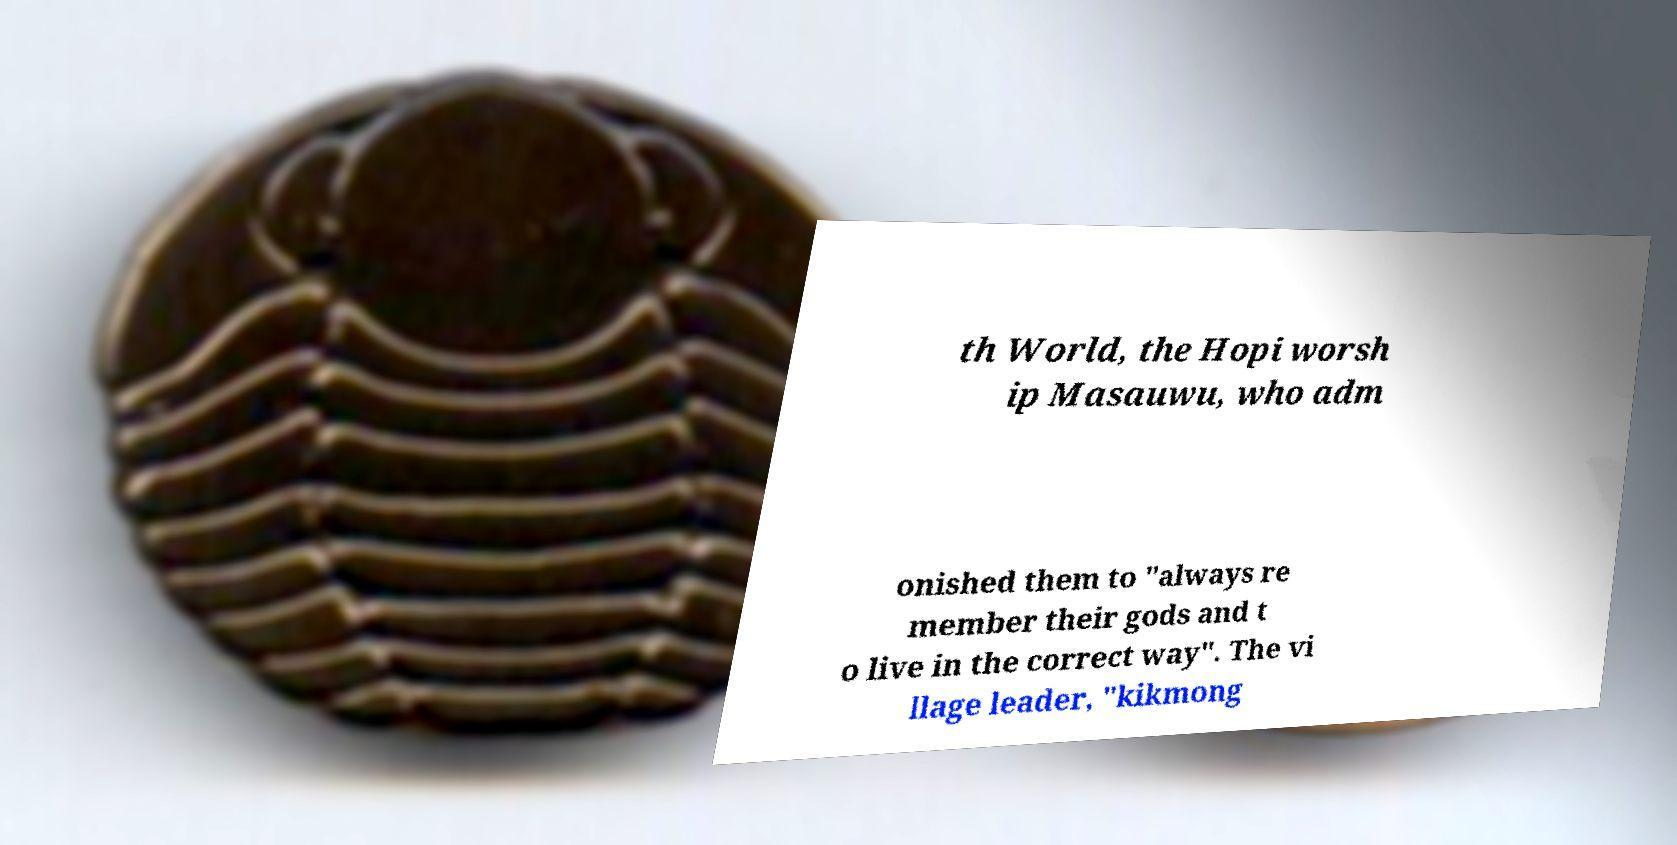Can you read and provide the text displayed in the image?This photo seems to have some interesting text. Can you extract and type it out for me? th World, the Hopi worsh ip Masauwu, who adm onished them to "always re member their gods and t o live in the correct way". The vi llage leader, "kikmong 